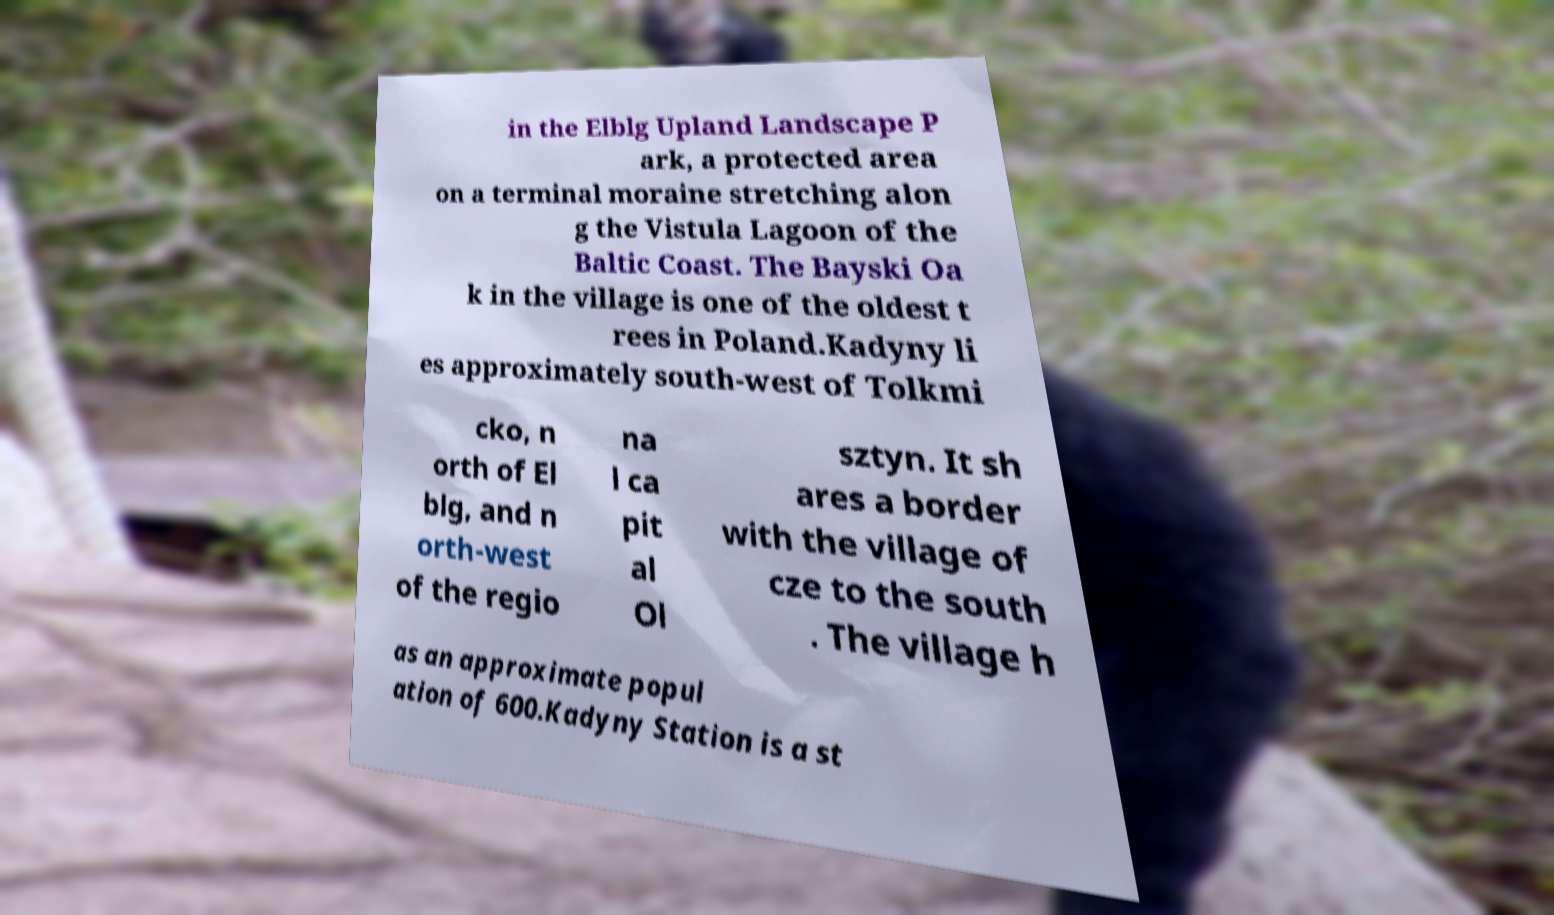I need the written content from this picture converted into text. Can you do that? in the Elblg Upland Landscape P ark, a protected area on a terminal moraine stretching alon g the Vistula Lagoon of the Baltic Coast. The Bayski Oa k in the village is one of the oldest t rees in Poland.Kadyny li es approximately south-west of Tolkmi cko, n orth of El blg, and n orth-west of the regio na l ca pit al Ol sztyn. It sh ares a border with the village of cze to the south . The village h as an approximate popul ation of 600.Kadyny Station is a st 